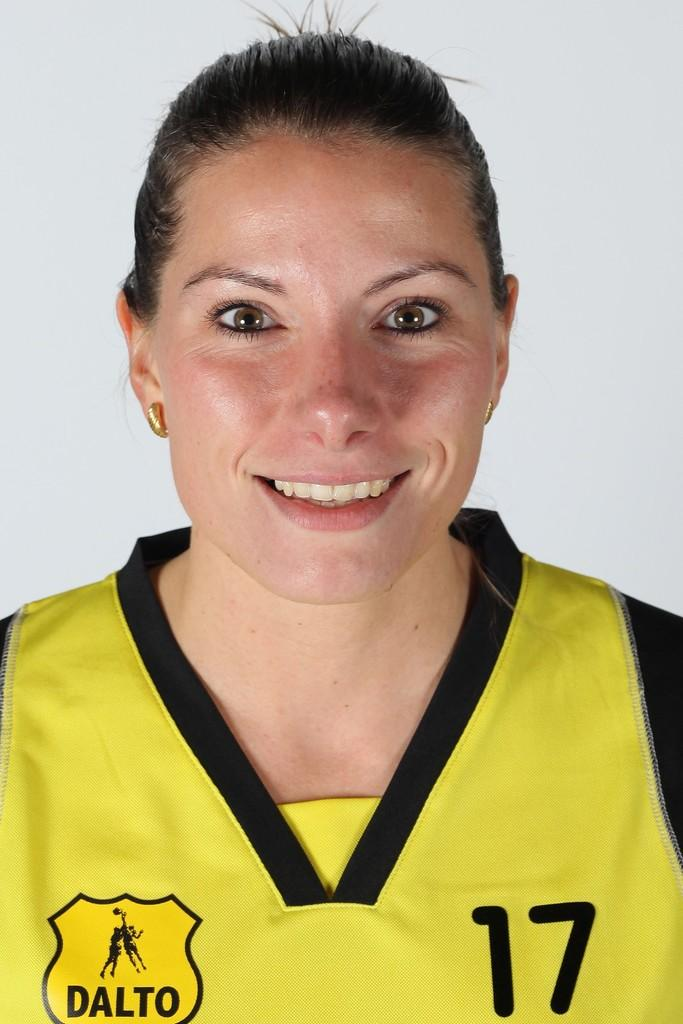Who is present in the image? There is a woman in the image. What expression does the woman have? The woman is smiling. What color is the background of the image? The background of the image is white. What type of stream can be seen in the background of the image? There is no stream present in the image; the background is white. 